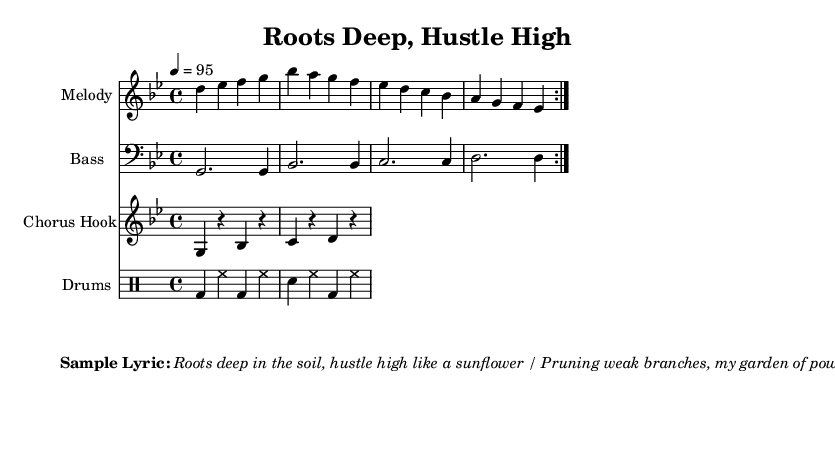What is the key signature of this music? The key signature can be found in the beginning of the sheet music, right after the clef. The presence of two flats indicates that the key signature is G minor.
Answer: G minor What is the time signature of this music? The time signature appears at the beginning of the music, represented as a fraction. Here, it is marked as 4/4, which indicates four beats per measure.
Answer: 4/4 What is the tempo marking for this piece? The tempo marking is indicated by the number below the respective tempo sign. In this sheet music, the marking states "4 = 95," meaning 95 beats per minute.
Answer: 95 How many measures are in the melody section? By examining the melody portion of the sheet music, we count the number of complete repetitions indicated by the repeat signs and the individual measures. There are a total of four measures repeated twice, resulting in eight measures.
Answer: 8 What type of rhythm is used in the drums section? The rhythm shown in the drums section consists of a combination of bass drum (bd), hi-hat (hh), and snare drum (sn), alternating in a consistent four-beat pattern. This reflects typical rhythms found in rap music.
Answer: Four-beat pattern What is the overall theme reflected in the lyrics? The lyrics presented depict themes of growth and strength, employing metaphors related to gardening, such as "Roots deep in the soil" and "Pruning weak branches," illustrating resilience and nurturing in one's environment and endeavors.
Answer: Growth and strength 